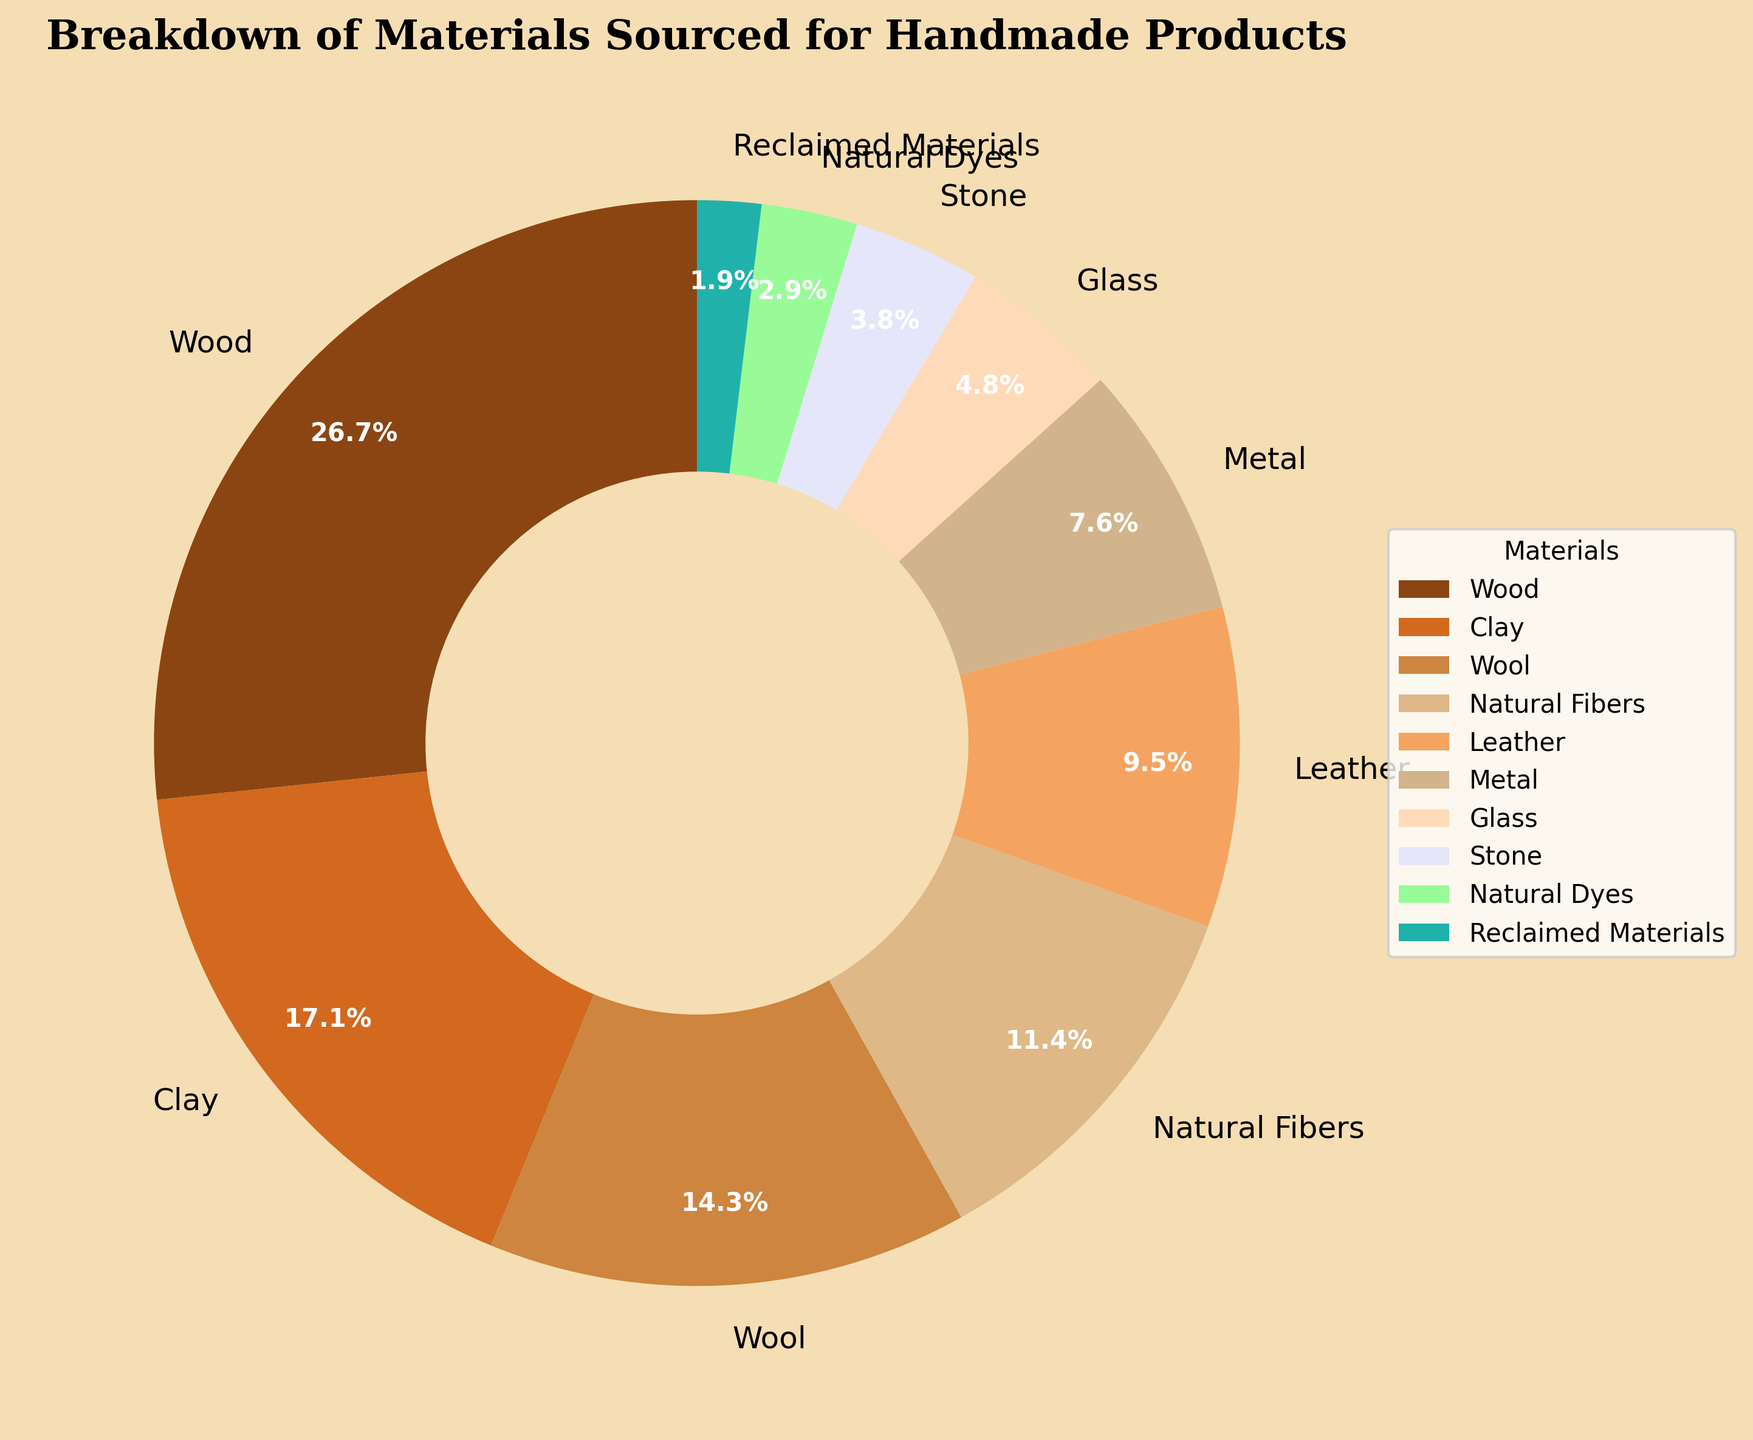what material makes up the smallest percentage in the pie chart? The smallest percentage in the pie chart is identified by finding the material with the lowest percentage value. From the data, Reclaimed Materials have the lowest percentage at 2%.
Answer: Reclaimed Materials Which material exceeds the percentage of Metal but falls short of Clay? First, identify the percentage values of Metal (8%) and Clay (18%). The material that falls between these values is Leather, which has a percentage of 10%.
Answer: Leather What is the combined percentage of Wood and Natural Fibers? Add the percentage values of Wood (28%) and Natural Fibers (12%). The sum is 28% + 12% = 40%.
Answer: 40% Is the current share of Wool greater than or less than the share of Metal? Compare the percentages of Wool (15%) and Metal (8%). Wool's share is greater than Metal's.
Answer: Greater What is the total percentage of the top three materials? Sum the percentages of the top three materials: Wood (28%), Clay (18%), and Wool (15%). The total is 28% + 18% + 15% = 61%.
Answer: 61% Which material occupies a 12% share of the pie chart? Identify the material with a 12% share from the data, which is Natural Fibers.
Answer: Natural Fibers What is the difference between the percentage of Glass and Stone? Subtract Stone's percentage (4%) from Glass's percentage (5%). The difference is 5% - 4% = 1%.
Answer: 1% Which material is represented by the color green in the pie chart? The green color from the rustic palette is associated with Natural Dyes, as green corresponds to '#98FB98' in the color list.
Answer: Natural Dyes What is the average percentage of the materials that have more than 15% share? Identify the materials with more than 15% share: Wood (28%), Clay (18%), and Wool (15%). The average is (28% + 18% + 15%) / 3 = 61% / 3 = 20.33%.
Answer: 20.33% Are there more materials with a percentage higher than 10% or less than 10%? Count the materials greater than 10%: Wood, Clay, Wool, Natural Fibers, Leather (5 materials). Count the materials less than 10%: Metal, Glass, Stone, Natural Dyes, Reclaimed Materials (5 materials). Both categories have equal counts.
Answer: Equal 